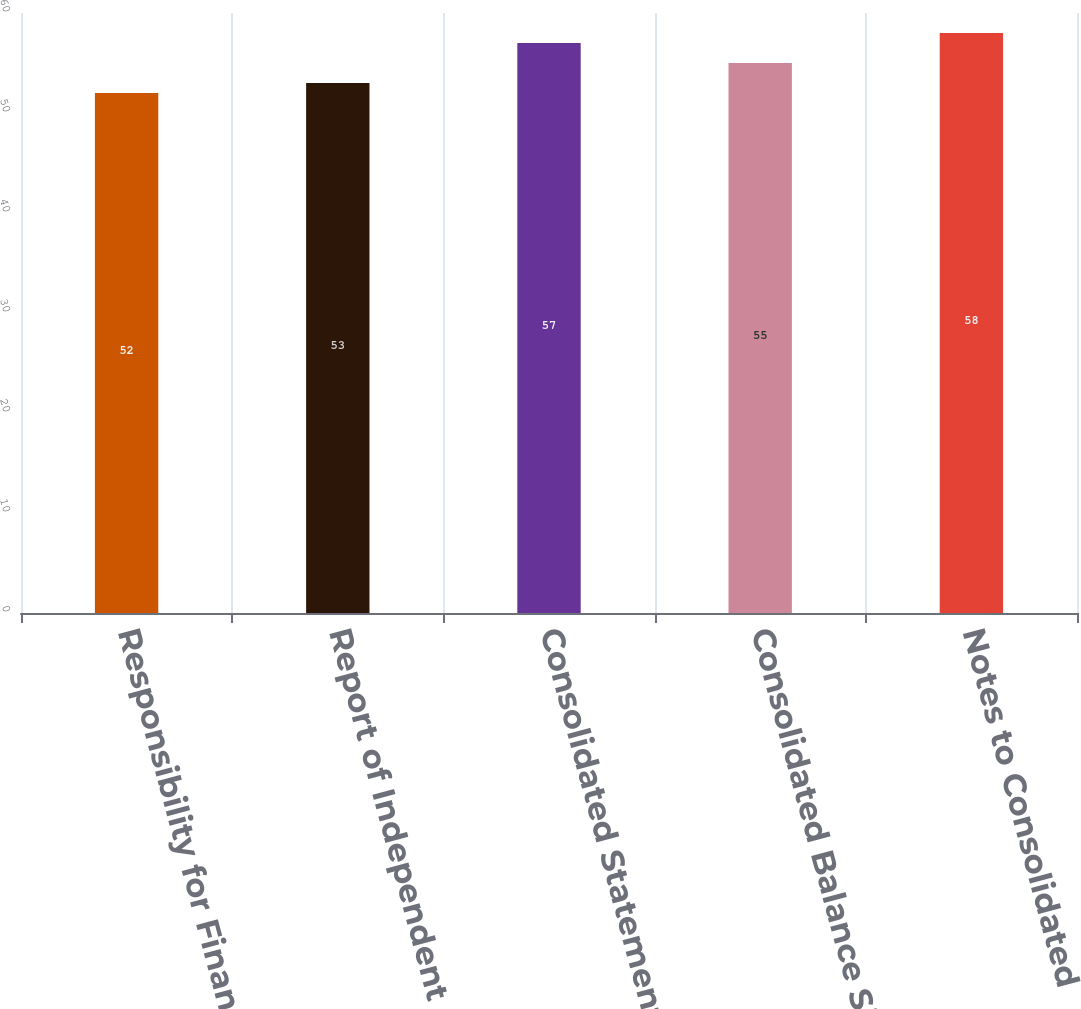<chart> <loc_0><loc_0><loc_500><loc_500><bar_chart><fcel>Responsibility for Financial<fcel>Report of Independent<fcel>Consolidated Statements of<fcel>Consolidated Balance Sheets as<fcel>Notes to Consolidated<nl><fcel>52<fcel>53<fcel>57<fcel>55<fcel>58<nl></chart> 